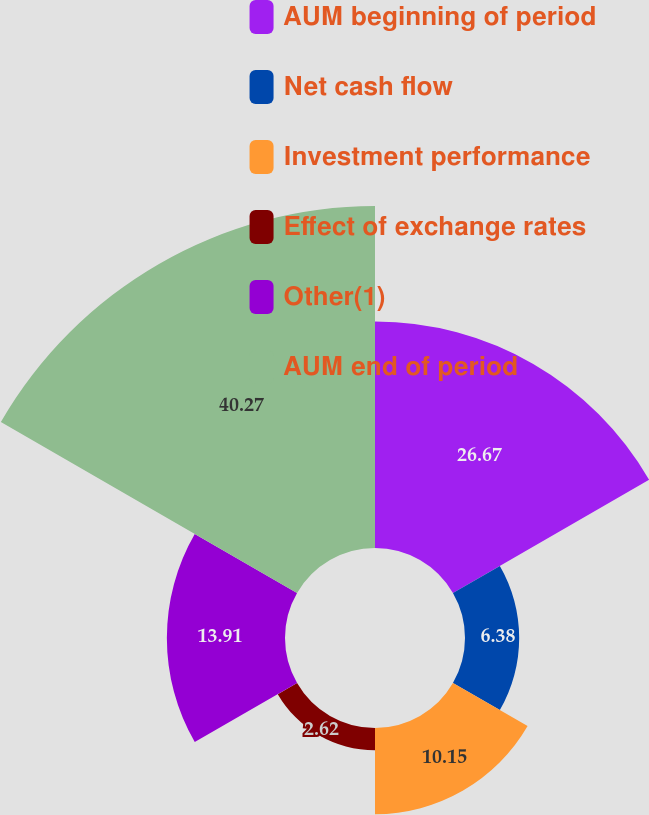Convert chart to OTSL. <chart><loc_0><loc_0><loc_500><loc_500><pie_chart><fcel>AUM beginning of period<fcel>Net cash flow<fcel>Investment performance<fcel>Effect of exchange rates<fcel>Other(1)<fcel>AUM end of period<nl><fcel>26.67%<fcel>6.38%<fcel>10.15%<fcel>2.62%<fcel>13.91%<fcel>40.27%<nl></chart> 